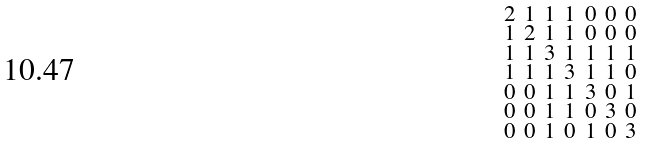Convert formula to latex. <formula><loc_0><loc_0><loc_500><loc_500>\begin{smallmatrix} 2 & 1 & 1 & 1 & 0 & 0 & 0 \\ 1 & 2 & 1 & 1 & 0 & 0 & 0 \\ 1 & 1 & 3 & 1 & 1 & 1 & 1 \\ 1 & 1 & 1 & 3 & 1 & 1 & 0 \\ 0 & 0 & 1 & 1 & 3 & 0 & 1 \\ 0 & 0 & 1 & 1 & 0 & 3 & 0 \\ 0 & 0 & 1 & 0 & 1 & 0 & 3 \end{smallmatrix}</formula> 